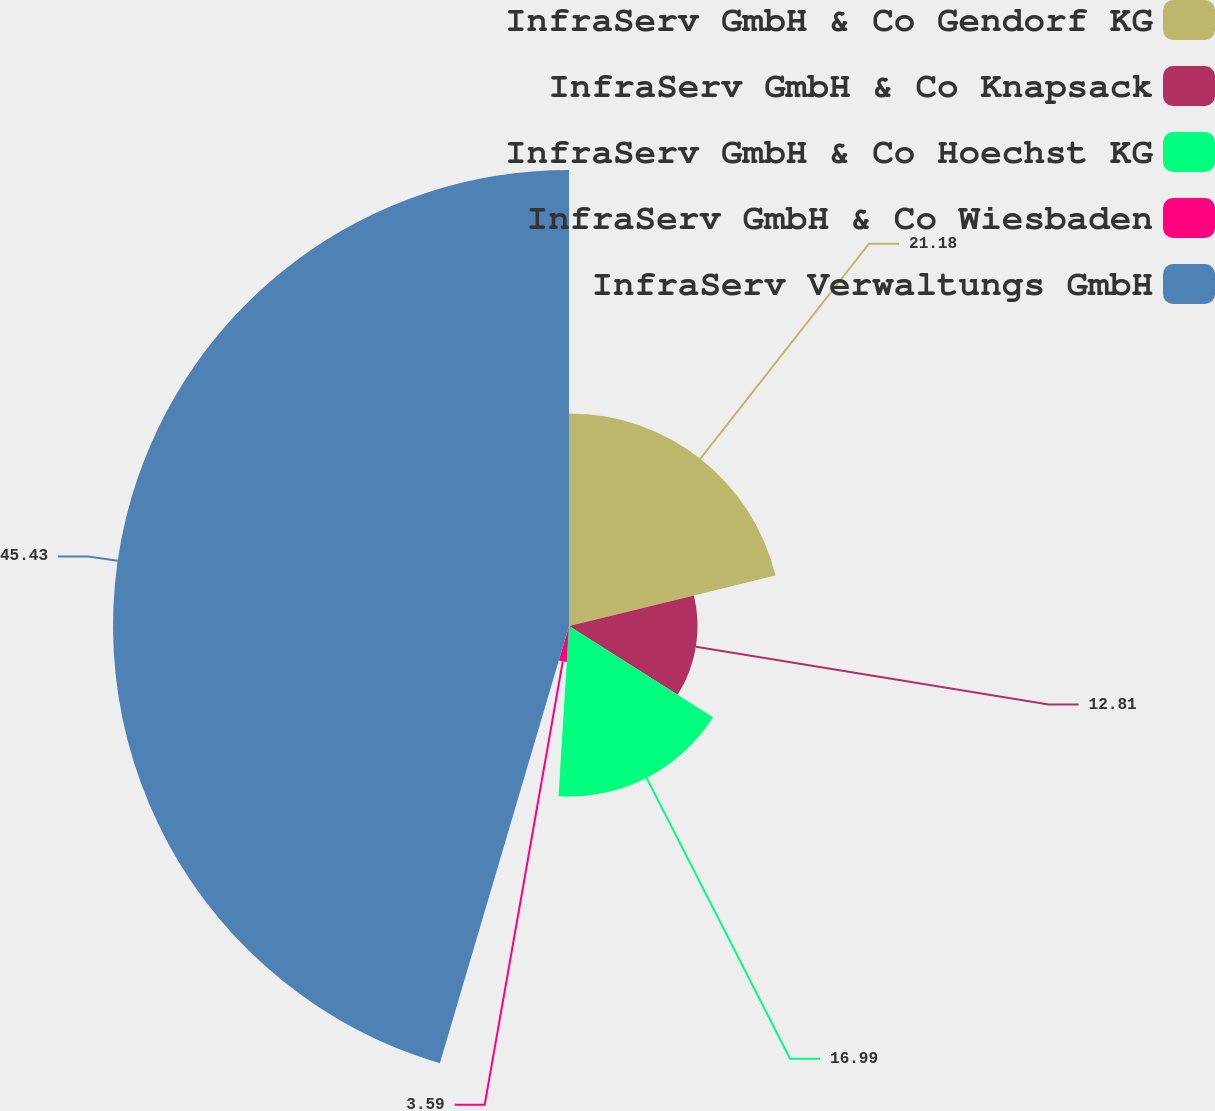<chart> <loc_0><loc_0><loc_500><loc_500><pie_chart><fcel>InfraServ GmbH & Co Gendorf KG<fcel>InfraServ GmbH & Co Knapsack<fcel>InfraServ GmbH & Co Hoechst KG<fcel>InfraServ GmbH & Co Wiesbaden<fcel>InfraServ Verwaltungs GmbH<nl><fcel>21.18%<fcel>12.81%<fcel>16.99%<fcel>3.59%<fcel>45.43%<nl></chart> 